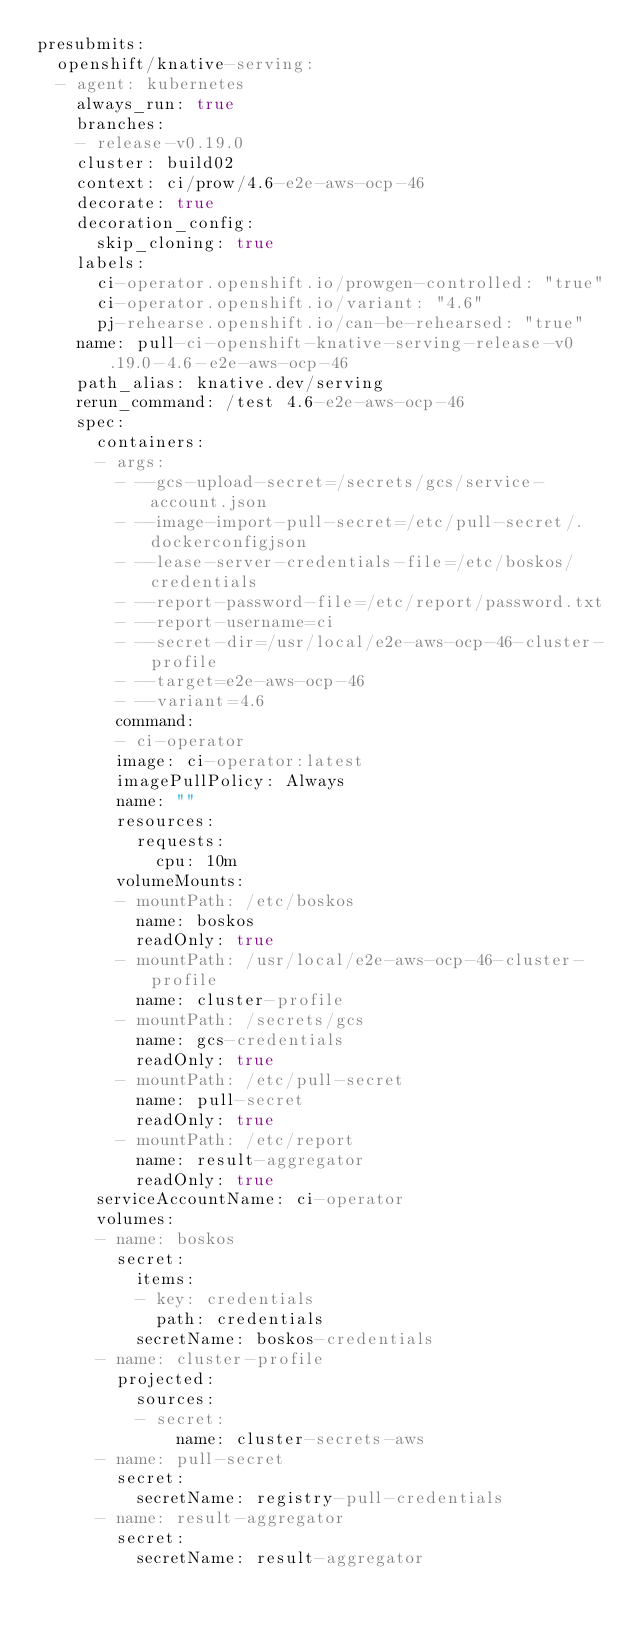Convert code to text. <code><loc_0><loc_0><loc_500><loc_500><_YAML_>presubmits:
  openshift/knative-serving:
  - agent: kubernetes
    always_run: true
    branches:
    - release-v0.19.0
    cluster: build02
    context: ci/prow/4.6-e2e-aws-ocp-46
    decorate: true
    decoration_config:
      skip_cloning: true
    labels:
      ci-operator.openshift.io/prowgen-controlled: "true"
      ci-operator.openshift.io/variant: "4.6"
      pj-rehearse.openshift.io/can-be-rehearsed: "true"
    name: pull-ci-openshift-knative-serving-release-v0.19.0-4.6-e2e-aws-ocp-46
    path_alias: knative.dev/serving
    rerun_command: /test 4.6-e2e-aws-ocp-46
    spec:
      containers:
      - args:
        - --gcs-upload-secret=/secrets/gcs/service-account.json
        - --image-import-pull-secret=/etc/pull-secret/.dockerconfigjson
        - --lease-server-credentials-file=/etc/boskos/credentials
        - --report-password-file=/etc/report/password.txt
        - --report-username=ci
        - --secret-dir=/usr/local/e2e-aws-ocp-46-cluster-profile
        - --target=e2e-aws-ocp-46
        - --variant=4.6
        command:
        - ci-operator
        image: ci-operator:latest
        imagePullPolicy: Always
        name: ""
        resources:
          requests:
            cpu: 10m
        volumeMounts:
        - mountPath: /etc/boskos
          name: boskos
          readOnly: true
        - mountPath: /usr/local/e2e-aws-ocp-46-cluster-profile
          name: cluster-profile
        - mountPath: /secrets/gcs
          name: gcs-credentials
          readOnly: true
        - mountPath: /etc/pull-secret
          name: pull-secret
          readOnly: true
        - mountPath: /etc/report
          name: result-aggregator
          readOnly: true
      serviceAccountName: ci-operator
      volumes:
      - name: boskos
        secret:
          items:
          - key: credentials
            path: credentials
          secretName: boskos-credentials
      - name: cluster-profile
        projected:
          sources:
          - secret:
              name: cluster-secrets-aws
      - name: pull-secret
        secret:
          secretName: registry-pull-credentials
      - name: result-aggregator
        secret:
          secretName: result-aggregator</code> 